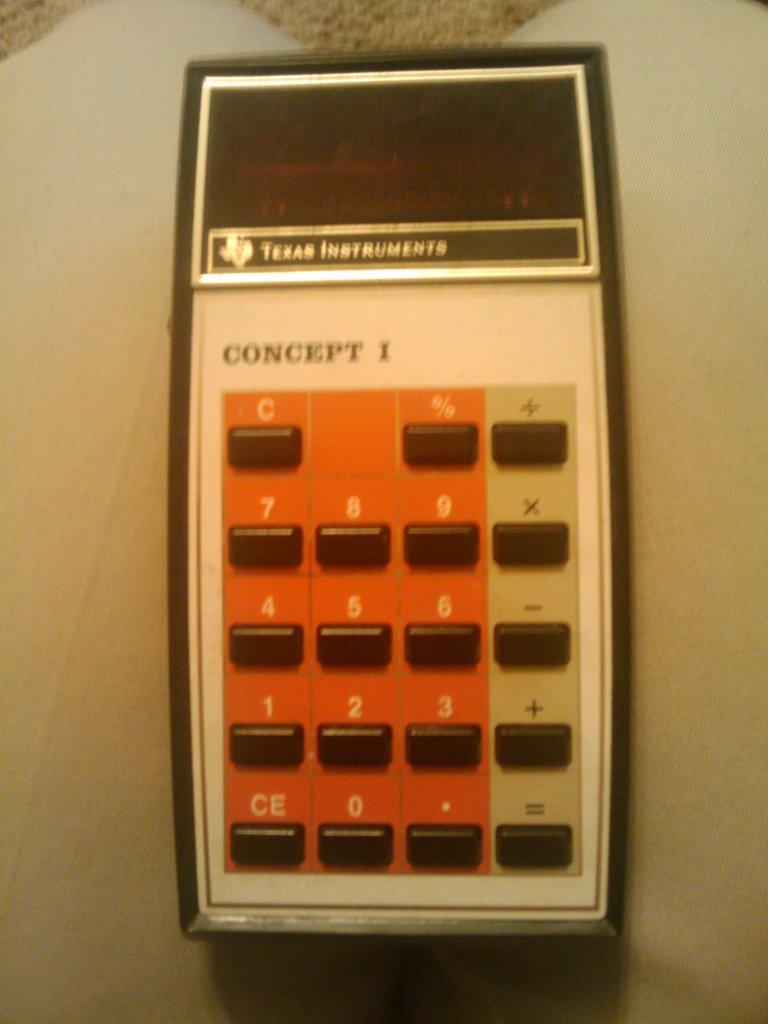<image>
Give a short and clear explanation of the subsequent image. A concept I calculator made my Texas Instruments. 